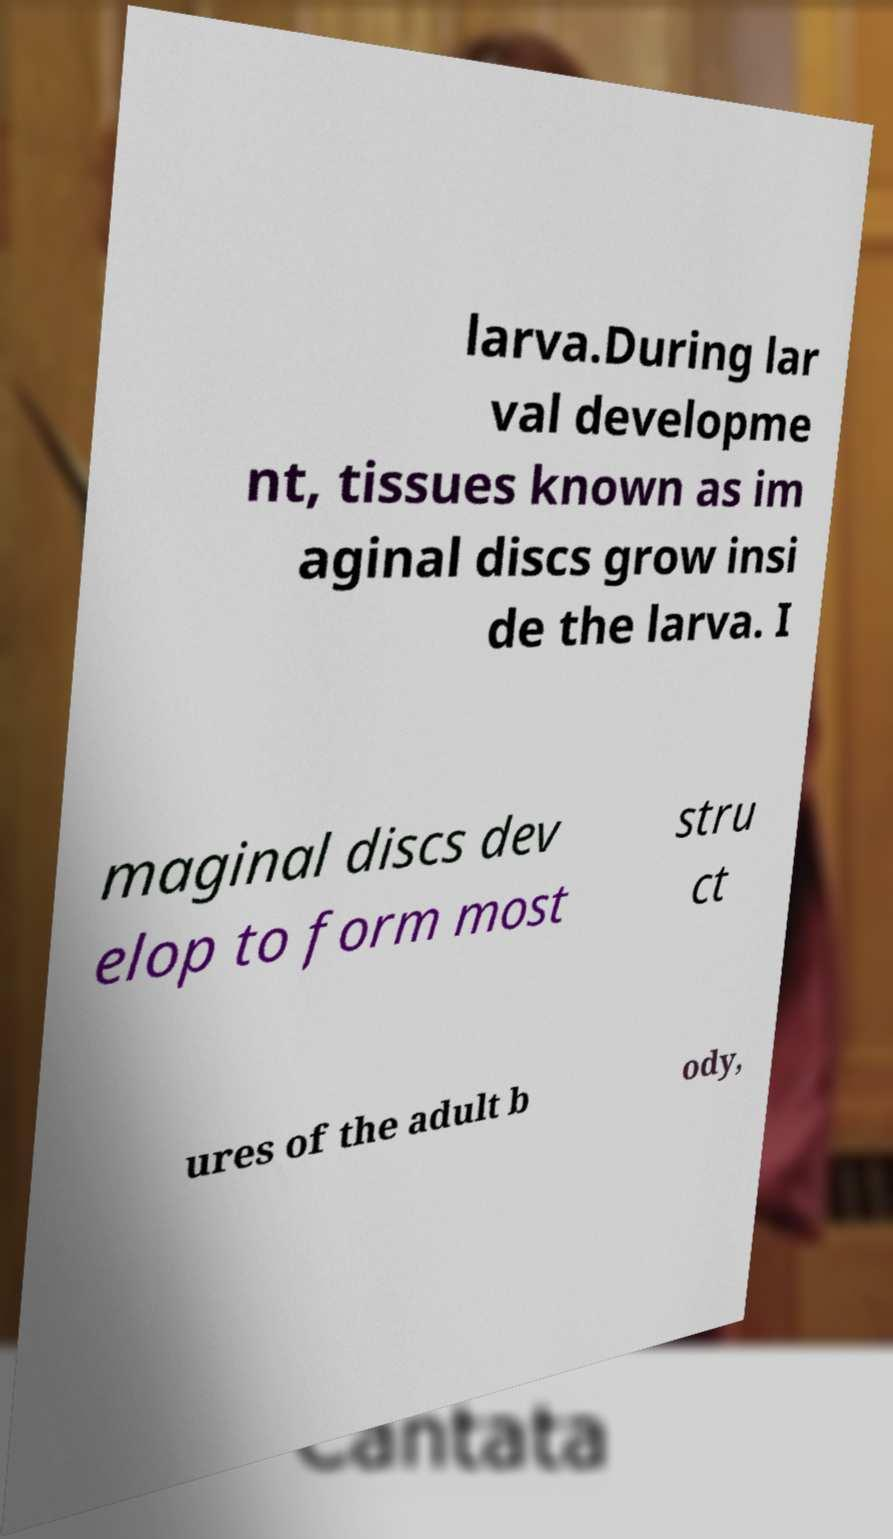Please identify and transcribe the text found in this image. larva.During lar val developme nt, tissues known as im aginal discs grow insi de the larva. I maginal discs dev elop to form most stru ct ures of the adult b ody, 